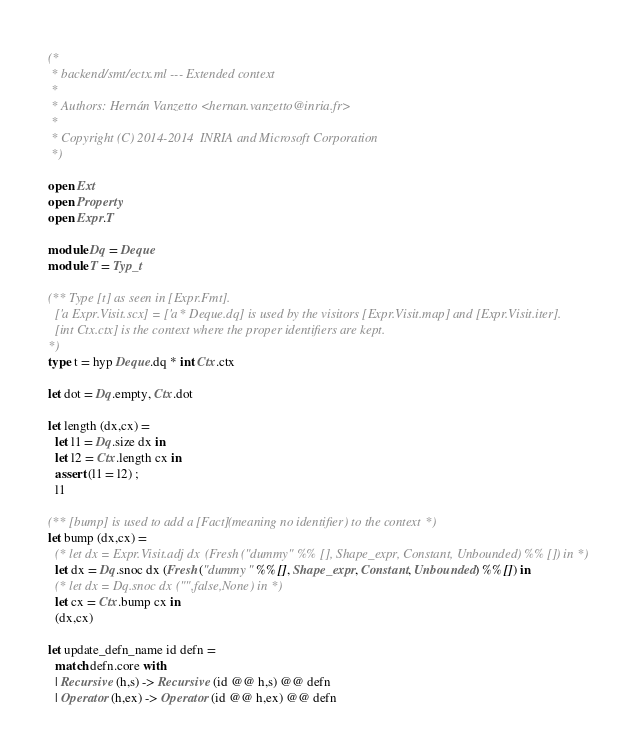Convert code to text. <code><loc_0><loc_0><loc_500><loc_500><_OCaml_>(*
 * backend/smt/ectx.ml --- Extended context
 *
 * Authors: Hernán Vanzetto <hernan.vanzetto@inria.fr>
 *
 * Copyright (C) 2014-2014  INRIA and Microsoft Corporation
 *)

open Ext
open Property
open Expr.T

module Dq = Deque
module T = Typ_t

(** Type [t] as seen in [Expr.Fmt].
  ['a Expr.Visit.scx] = ['a * Deque.dq] is used by the visitors [Expr.Visit.map] and [Expr.Visit.iter].
  [int Ctx.ctx] is the context where the proper identifiers are kept.
*)
type t = hyp Deque.dq * int Ctx.ctx

let dot = Dq.empty, Ctx.dot

let length (dx,cx) =
  let l1 = Dq.size dx in
  let l2 = Ctx.length cx in
  assert (l1 = l2) ;
  l1

(** [bump] is used to add a [Fact] (meaning no identifier) to the context *)
let bump (dx,cx) =
  (* let dx = Expr.Visit.adj dx (Fresh ("dummy" %% [], Shape_expr, Constant, Unbounded) %% []) in *)
  let dx = Dq.snoc dx (Fresh ("dummy" %% [], Shape_expr, Constant, Unbounded) %% []) in
  (* let dx = Dq.snoc dx ("",false,None) in *)
  let cx = Ctx.bump cx in
  (dx,cx)

let update_defn_name id defn = 
  match defn.core with
  | Recursive (h,s) -> Recursive (id @@ h,s) @@ defn
  | Operator (h,ex) -> Operator (id @@ h,ex) @@ defn</code> 